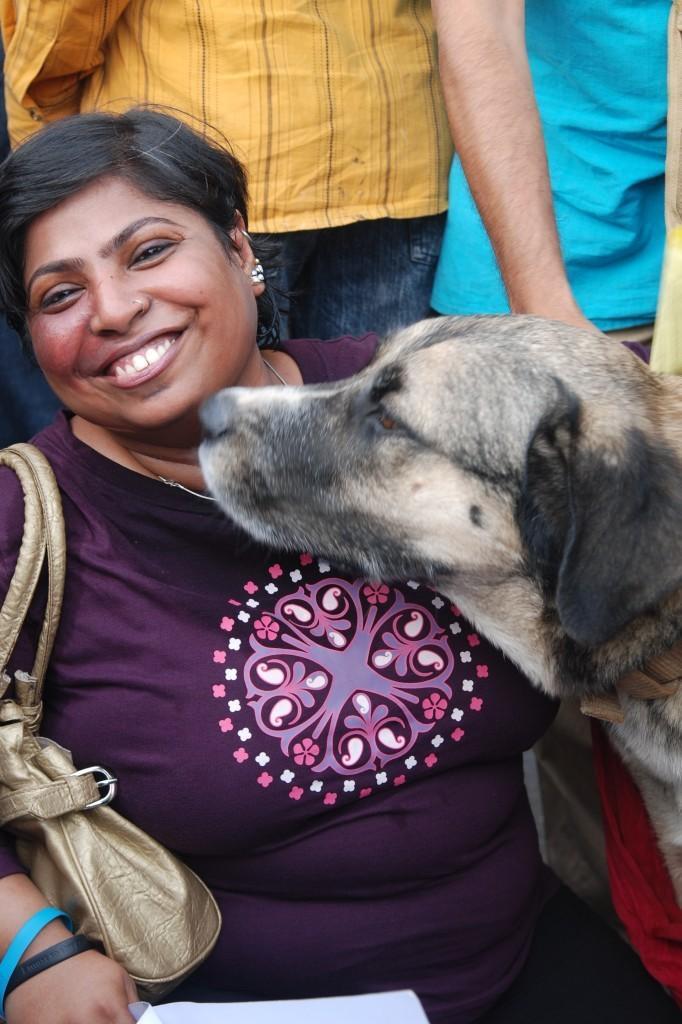How would you summarize this image in a sentence or two? On the left side of the image there is a woman smiling. On the right there is a dog. In the background there are people standing. 